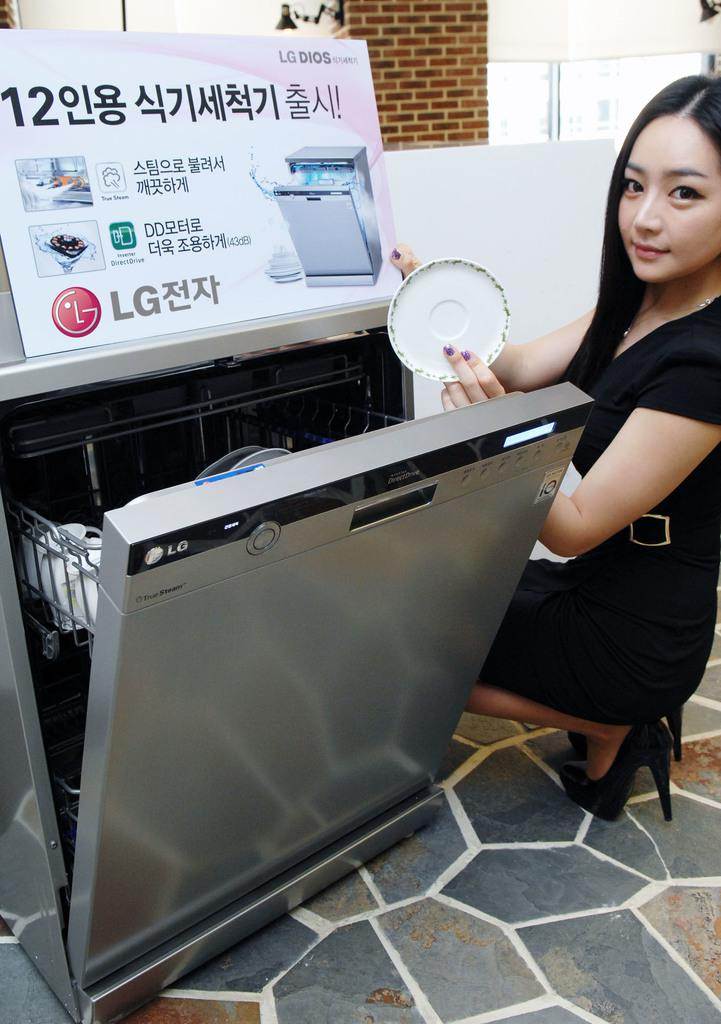Provide a one-sentence caption for the provided image. a women showing a clean dish out of an LG dishwasher. 